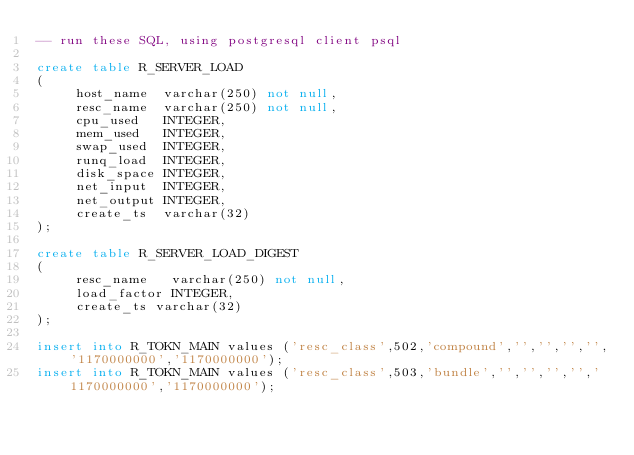<code> <loc_0><loc_0><loc_500><loc_500><_SQL_>-- run these SQL, using postgresql client psql 

create table R_SERVER_LOAD
(
     host_name  varchar(250) not null,
     resc_name  varchar(250) not null,
     cpu_used   INTEGER,
     mem_used   INTEGER,
     swap_used  INTEGER,
     runq_load  INTEGER,
     disk_space INTEGER,
     net_input  INTEGER,
     net_output INTEGER,
     create_ts  varchar(32)
);

create table R_SERVER_LOAD_DIGEST
(
     resc_name   varchar(250) not null,
     load_factor INTEGER,
     create_ts varchar(32)
);

insert into R_TOKN_MAIN values ('resc_class',502,'compound','','','','','1170000000','1170000000');
insert into R_TOKN_MAIN values ('resc_class',503,'bundle','','','','','1170000000','1170000000');
</code> 